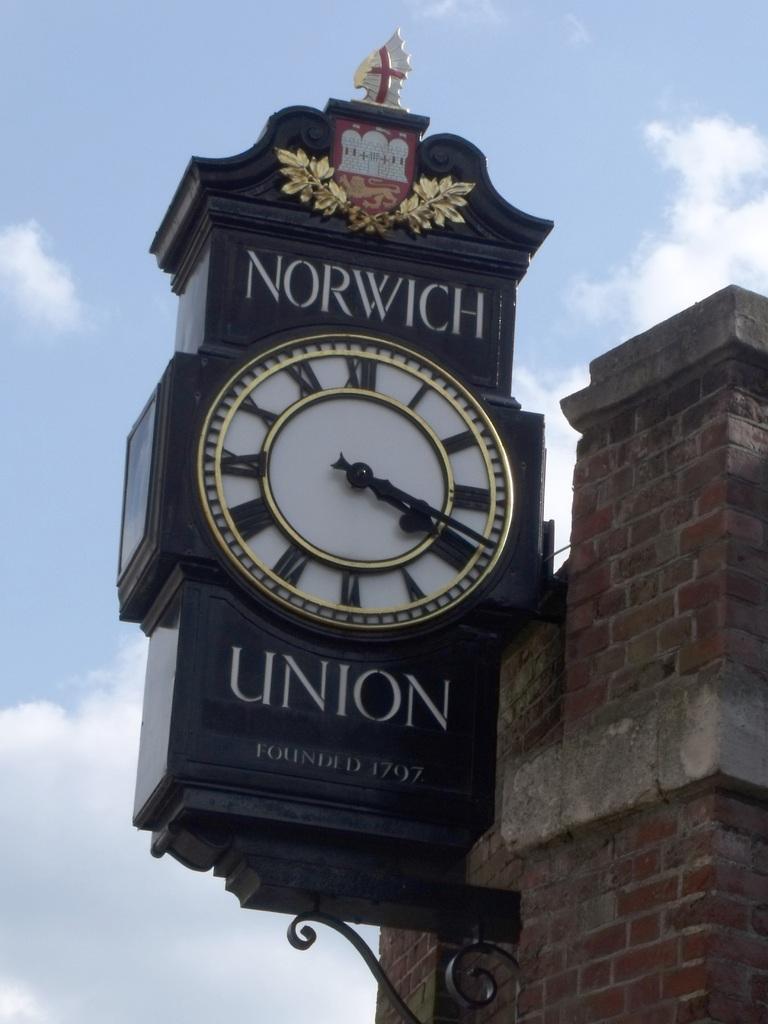What is the name of the place?
Make the answer very short. Norwich union. 